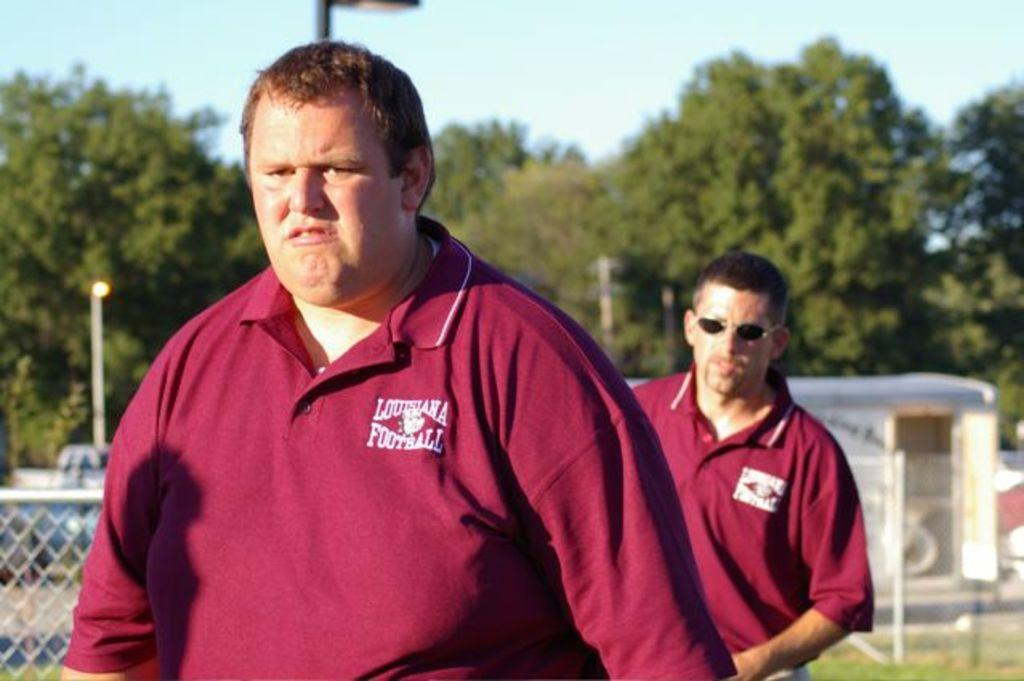<image>
Provide a brief description of the given image. Two men wearing maroon Louisana Football polo shirts walking outside. 